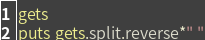Convert code to text. <code><loc_0><loc_0><loc_500><loc_500><_Ruby_>gets
puts gets.split.reverse*" "</code> 